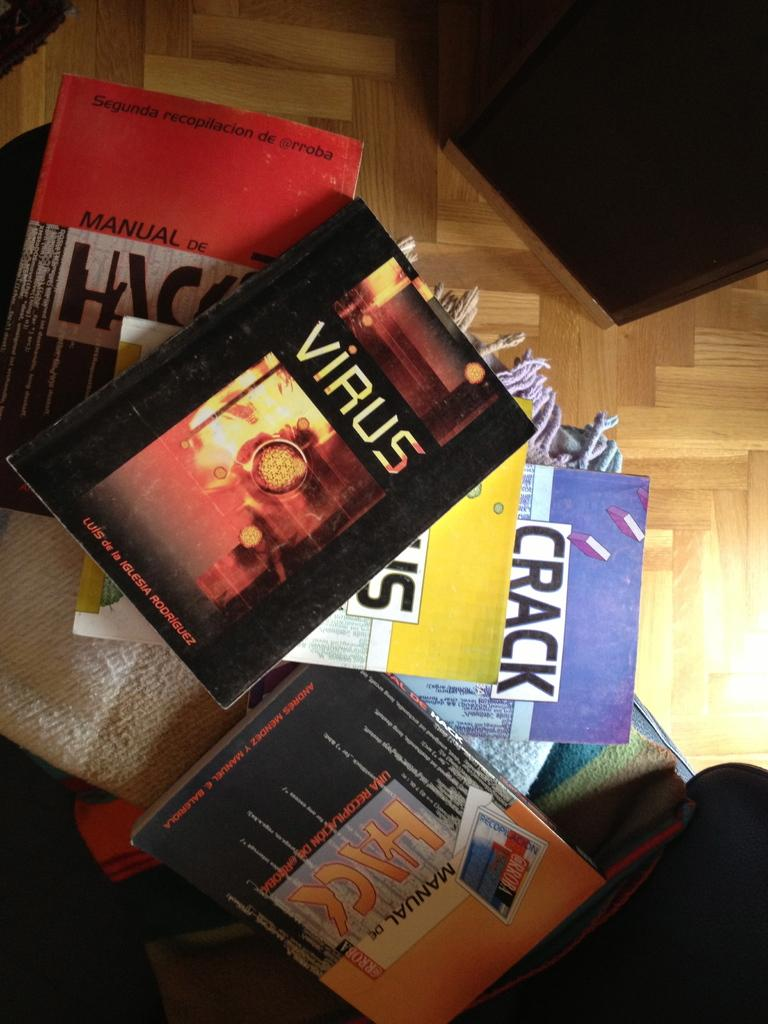<image>
Provide a brief description of the given image. A pile of books on the ground one of which is titled virus. 